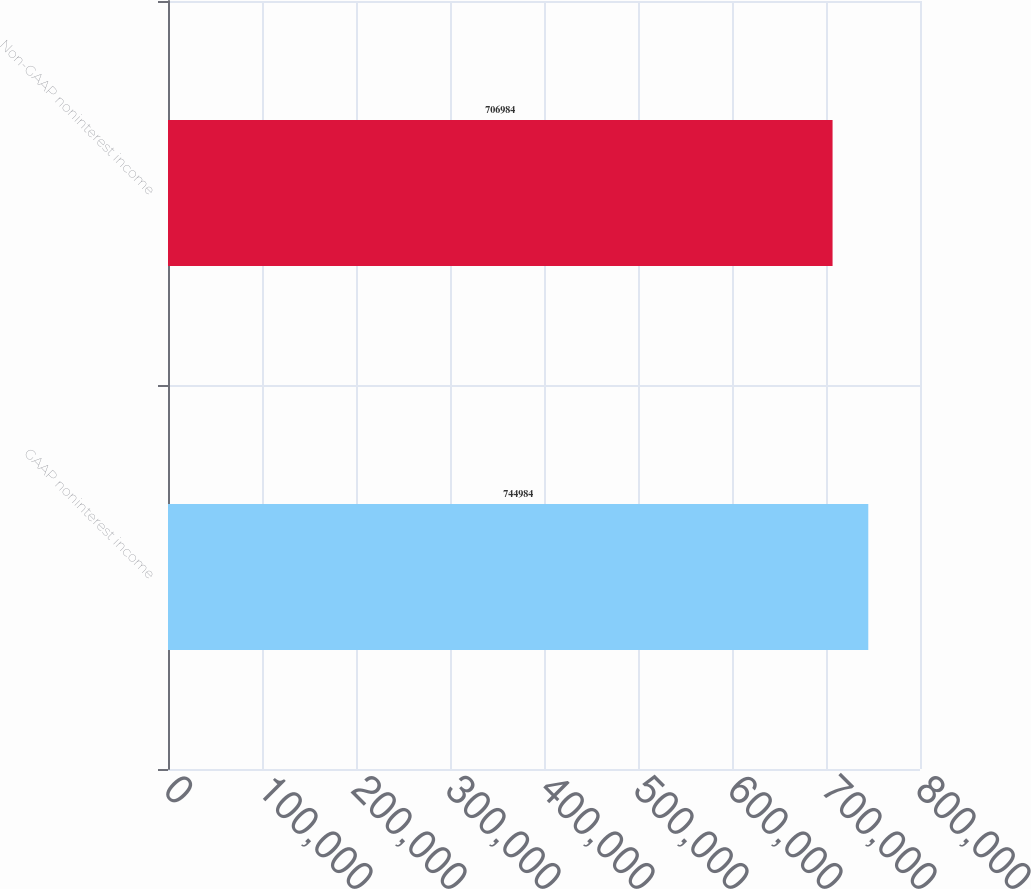Convert chart to OTSL. <chart><loc_0><loc_0><loc_500><loc_500><bar_chart><fcel>GAAP noninterest income<fcel>Non-GAAP noninterest income<nl><fcel>744984<fcel>706984<nl></chart> 